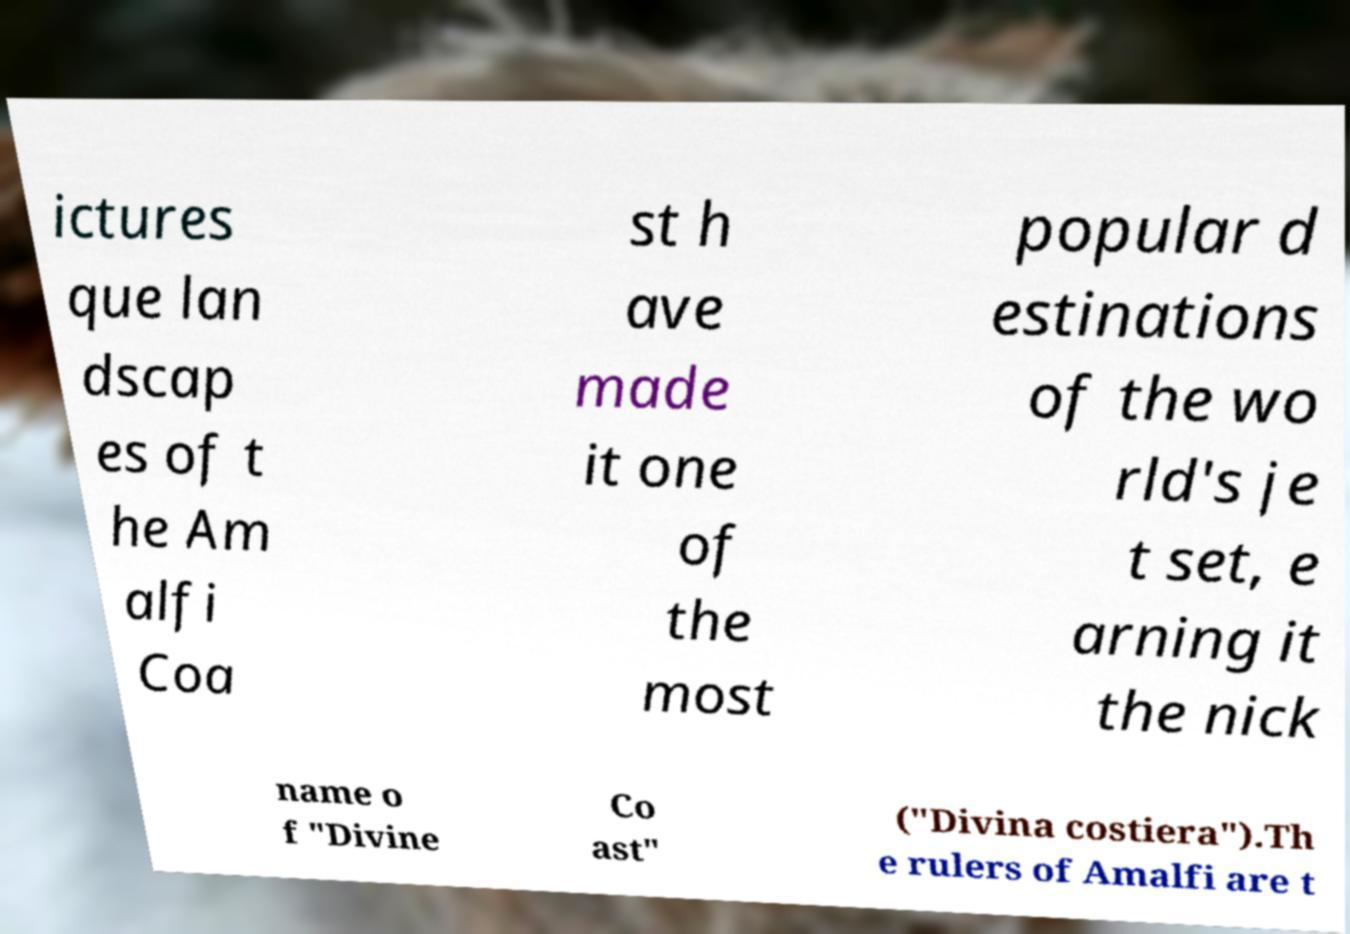For documentation purposes, I need the text within this image transcribed. Could you provide that? ictures que lan dscap es of t he Am alfi Coa st h ave made it one of the most popular d estinations of the wo rld's je t set, e arning it the nick name o f "Divine Co ast" ("Divina costiera").Th e rulers of Amalfi are t 